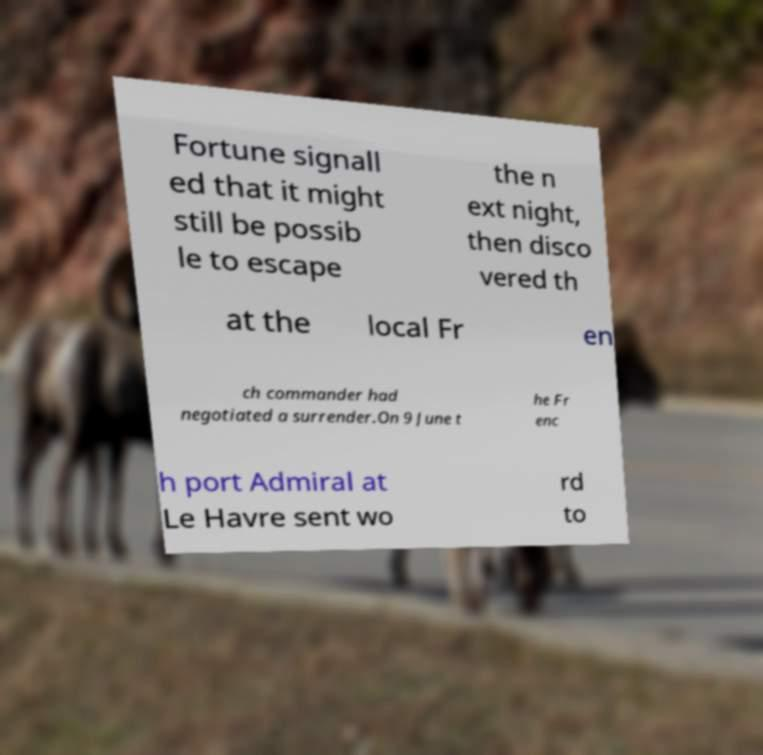Please read and relay the text visible in this image. What does it say? Fortune signall ed that it might still be possib le to escape the n ext night, then disco vered th at the local Fr en ch commander had negotiated a surrender.On 9 June t he Fr enc h port Admiral at Le Havre sent wo rd to 